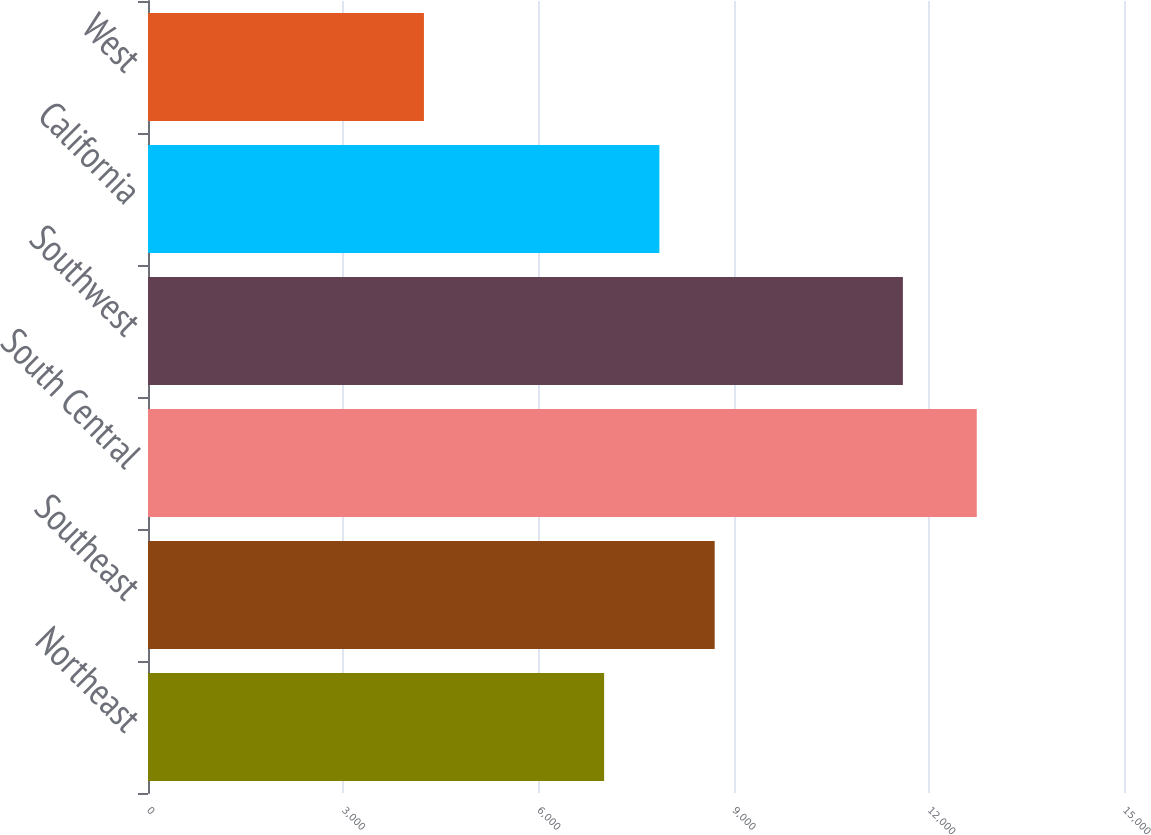Convert chart to OTSL. <chart><loc_0><loc_0><loc_500><loc_500><bar_chart><fcel>Northeast<fcel>Southeast<fcel>South Central<fcel>Southwest<fcel>California<fcel>West<nl><fcel>7010<fcel>8709.2<fcel>12737<fcel>11602<fcel>7859.6<fcel>4241<nl></chart> 